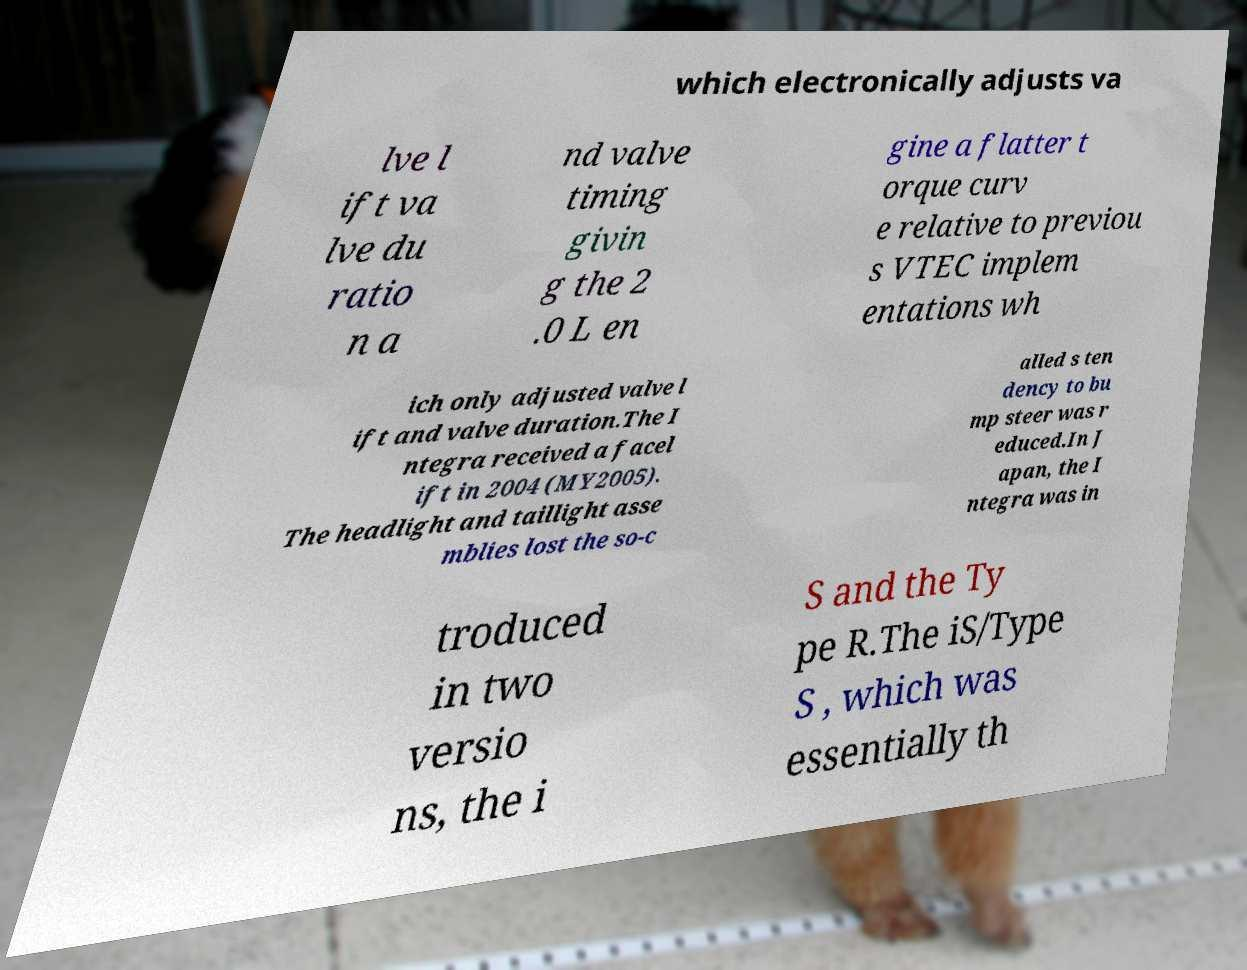Can you read and provide the text displayed in the image?This photo seems to have some interesting text. Can you extract and type it out for me? which electronically adjusts va lve l ift va lve du ratio n a nd valve timing givin g the 2 .0 L en gine a flatter t orque curv e relative to previou s VTEC implem entations wh ich only adjusted valve l ift and valve duration.The I ntegra received a facel ift in 2004 (MY2005). The headlight and taillight asse mblies lost the so-c alled s ten dency to bu mp steer was r educed.In J apan, the I ntegra was in troduced in two versio ns, the i S and the Ty pe R.The iS/Type S , which was essentially th 